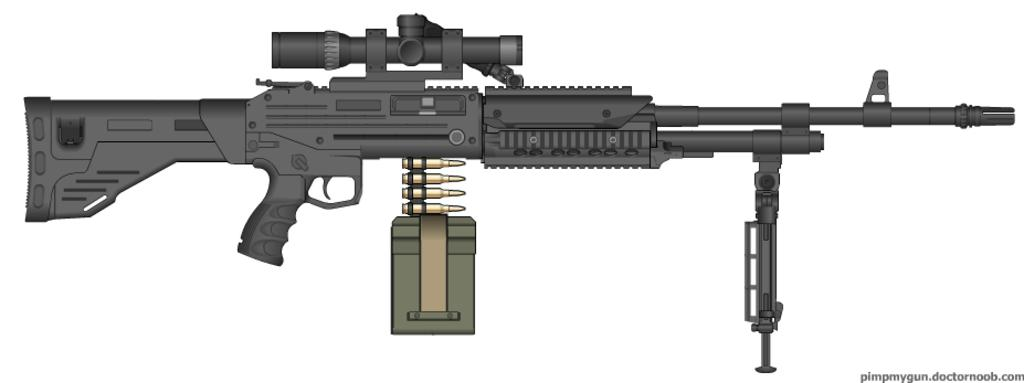What object is the main focus of the image? There is a gun in the image. Is there any text or writing present in the image? Yes, there is text or writing on the image. What color is the background of the image? The background of the image is white. What type of flowers can be seen growing in the image? There are no flowers present in the image; it features a gun and text or writing on a white background. What kind of steel is used to manufacture the gun in the image? The type of steel used to manufacture the gun cannot be determined from the image alone. 